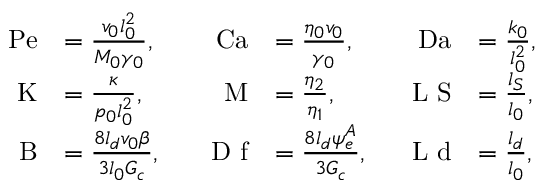Convert formula to latex. <formula><loc_0><loc_0><loc_500><loc_500>\begin{array} { r l r l r l } { P e } & { = \frac { v _ { 0 } l _ { 0 } ^ { 2 } } { M _ { 0 } \gamma _ { 0 } } , } & { \quad C a } & { = \frac { \eta _ { 0 } v _ { 0 } } { \gamma _ { 0 } } , } & { \quad D a } & { = \frac { k _ { 0 } } { l _ { 0 } ^ { 2 } } , } \\ { K } & { = \frac { \kappa } { p _ { 0 } l _ { 0 } ^ { 2 } } , } & { M } & { = \frac { \eta _ { 2 } } { \eta _ { 1 } } , } & { L \text  subscript S } & { = \frac{ } l _ { } { S } } { l _ { 0 } } , } \\ { \quad B } & { = \frac { 8 l _ { d } v _ { 0 } \beta } { 3 l _ { 0 } G _ { c } } , } & { \quad D \text  subscript f } & { = \frac{ } 8 l _ { } { d } \psi _ { } { e } ^ { } { A } } { 3 G _ { c } } , } & { L \text  subscript d } & { = \frac{ } l _ { } { d } } { l _ { 0 } } , } \end{array}</formula> 